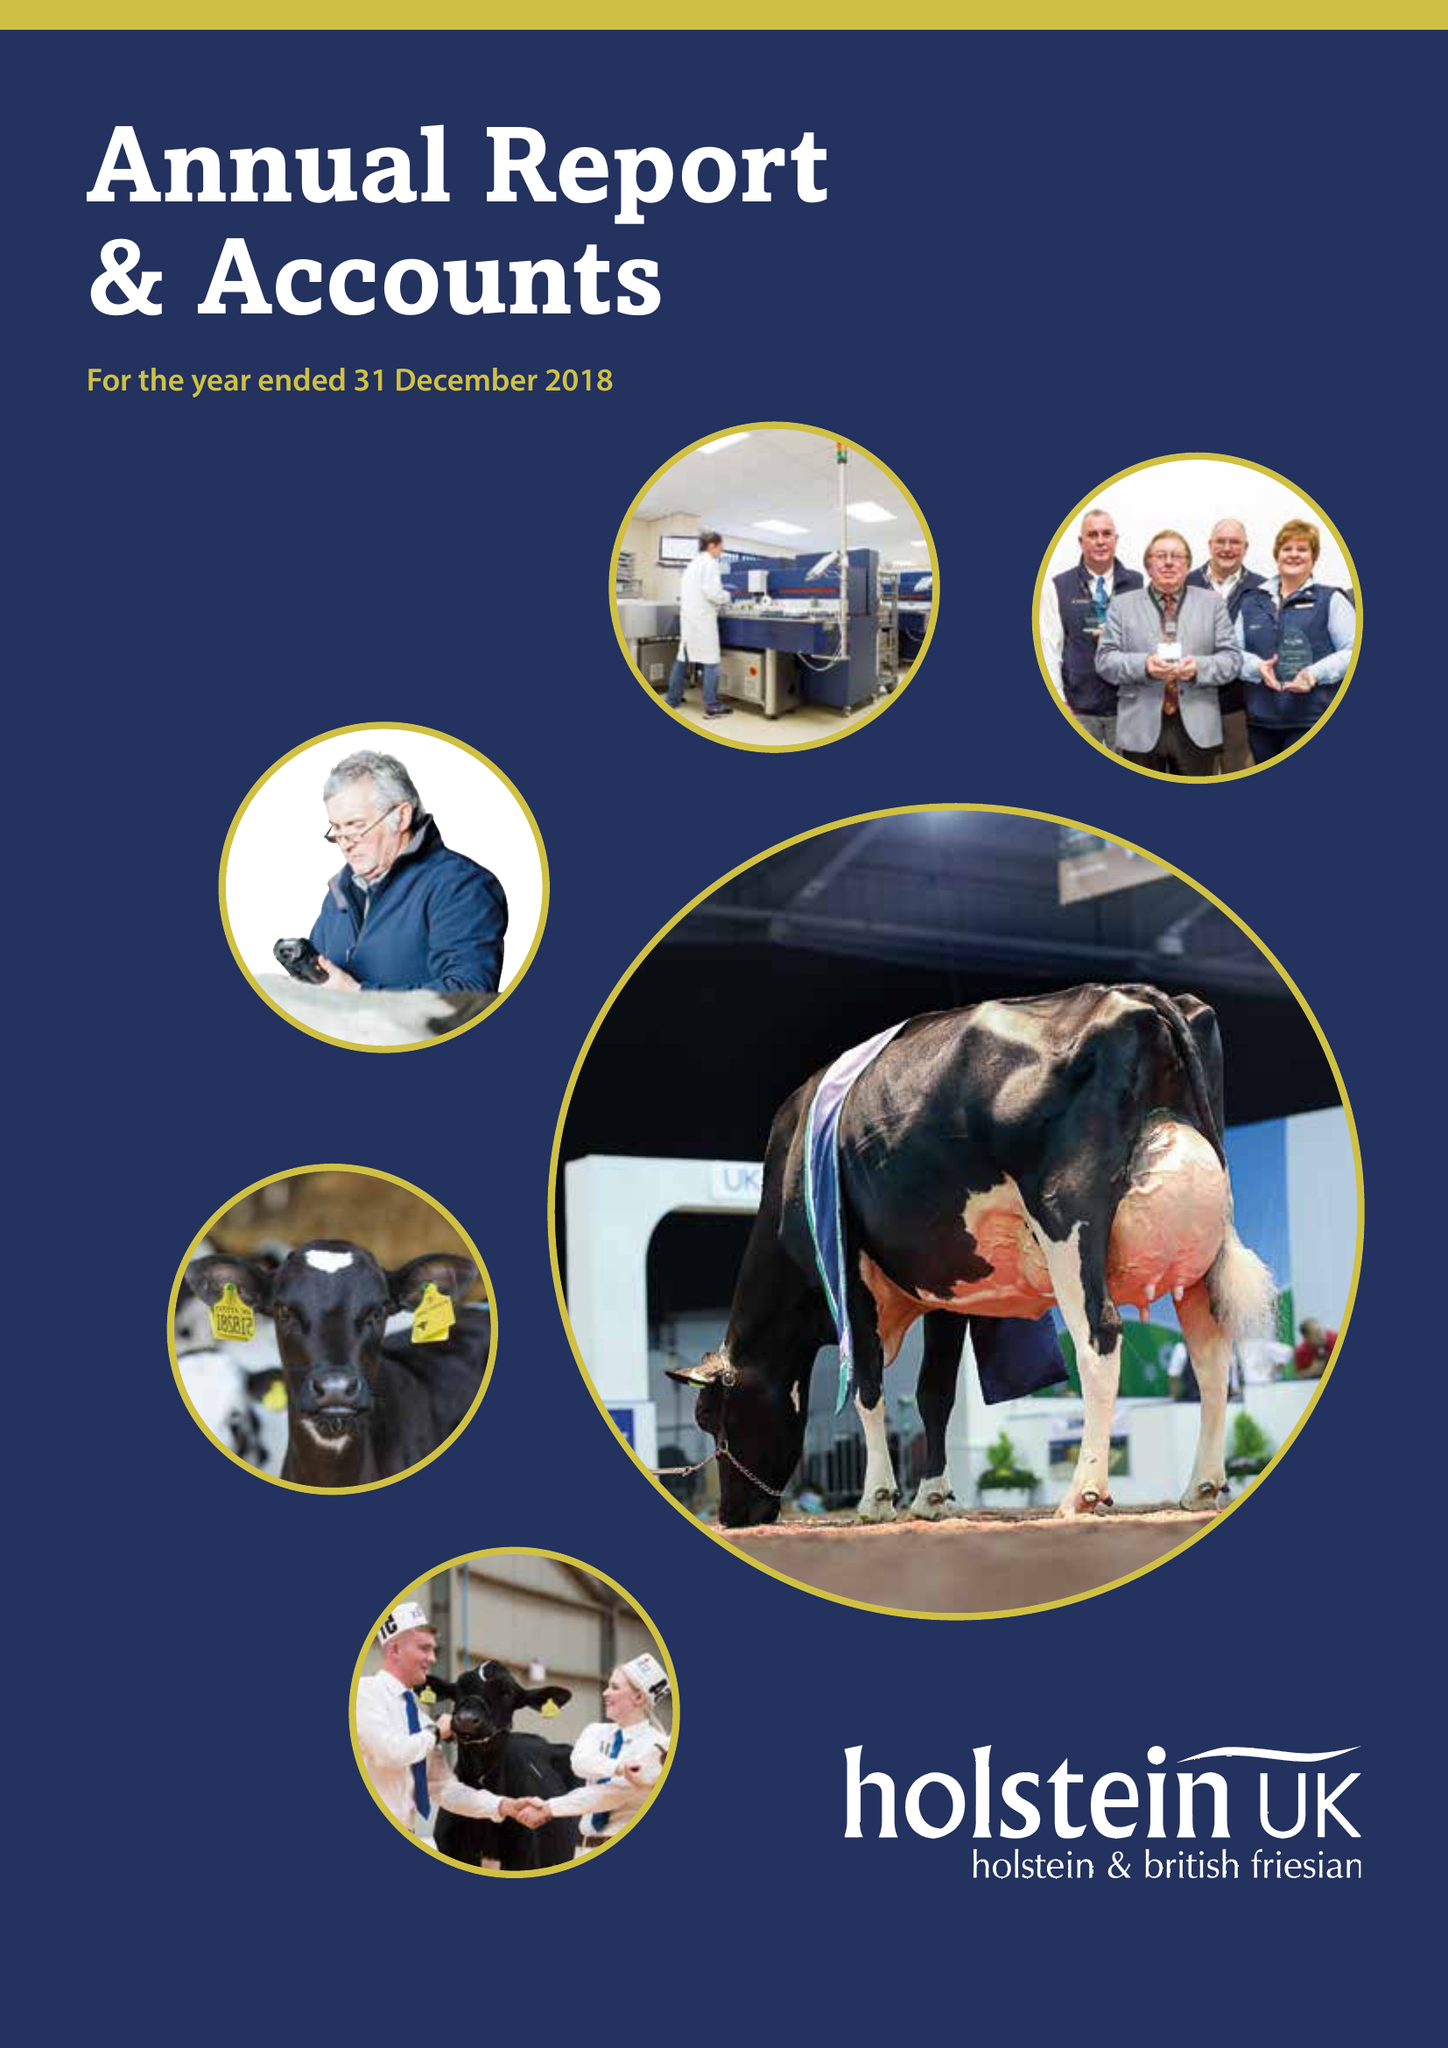What is the value for the charity_number?
Answer the question using a single word or phrase. 1072998 